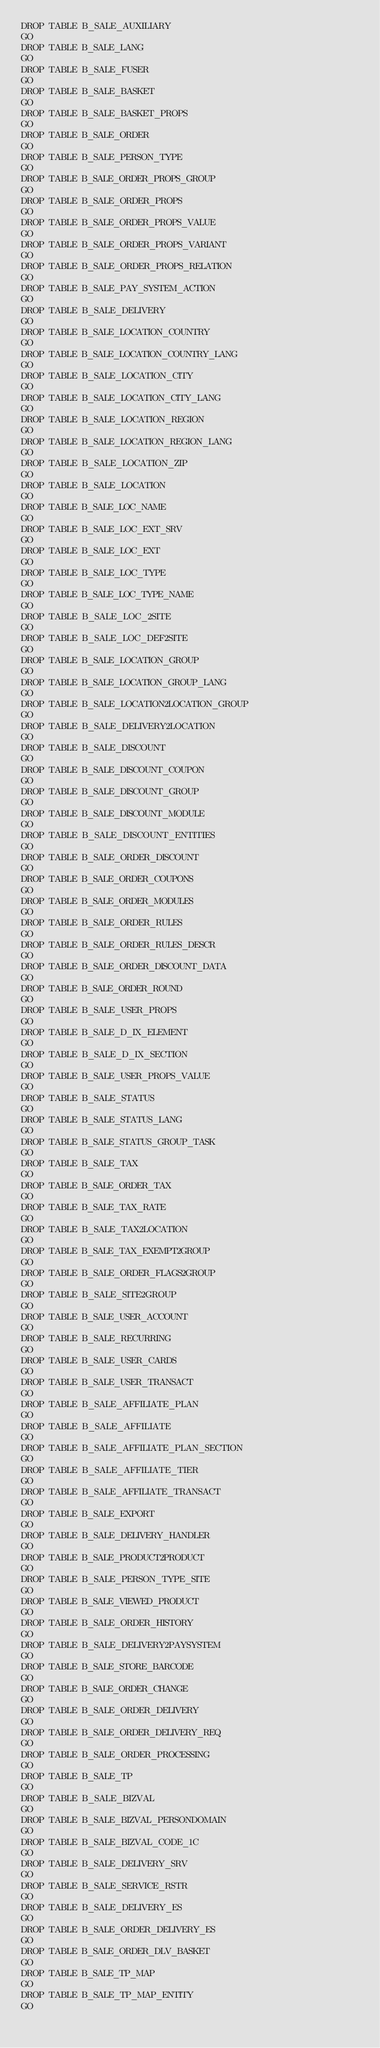Convert code to text. <code><loc_0><loc_0><loc_500><loc_500><_SQL_>DROP TABLE B_SALE_AUXILIARY
GO
DROP TABLE B_SALE_LANG
GO
DROP TABLE B_SALE_FUSER
GO
DROP TABLE B_SALE_BASKET
GO
DROP TABLE B_SALE_BASKET_PROPS
GO
DROP TABLE B_SALE_ORDER
GO
DROP TABLE B_SALE_PERSON_TYPE
GO
DROP TABLE B_SALE_ORDER_PROPS_GROUP
GO
DROP TABLE B_SALE_ORDER_PROPS
GO
DROP TABLE B_SALE_ORDER_PROPS_VALUE
GO
DROP TABLE B_SALE_ORDER_PROPS_VARIANT
GO
DROP TABLE B_SALE_ORDER_PROPS_RELATION
GO
DROP TABLE B_SALE_PAY_SYSTEM_ACTION
GO
DROP TABLE B_SALE_DELIVERY
GO
DROP TABLE B_SALE_LOCATION_COUNTRY
GO
DROP TABLE B_SALE_LOCATION_COUNTRY_LANG
GO
DROP TABLE B_SALE_LOCATION_CITY
GO
DROP TABLE B_SALE_LOCATION_CITY_LANG
GO
DROP TABLE B_SALE_LOCATION_REGION
GO
DROP TABLE B_SALE_LOCATION_REGION_LANG
GO
DROP TABLE B_SALE_LOCATION_ZIP
GO
DROP TABLE B_SALE_LOCATION
GO
DROP TABLE B_SALE_LOC_NAME
GO
DROP TABLE B_SALE_LOC_EXT_SRV
GO
DROP TABLE B_SALE_LOC_EXT
GO
DROP TABLE B_SALE_LOC_TYPE
GO
DROP TABLE B_SALE_LOC_TYPE_NAME
GO
DROP TABLE B_SALE_LOC_2SITE
GO
DROP TABLE B_SALE_LOC_DEF2SITE
GO
DROP TABLE B_SALE_LOCATION_GROUP
GO
DROP TABLE B_SALE_LOCATION_GROUP_LANG
GO
DROP TABLE B_SALE_LOCATION2LOCATION_GROUP
GO
DROP TABLE B_SALE_DELIVERY2LOCATION
GO
DROP TABLE B_SALE_DISCOUNT
GO
DROP TABLE B_SALE_DISCOUNT_COUPON
GO
DROP TABLE B_SALE_DISCOUNT_GROUP
GO
DROP TABLE B_SALE_DISCOUNT_MODULE
GO
DROP TABLE B_SALE_DISCOUNT_ENTITIES
GO
DROP TABLE B_SALE_ORDER_DISCOUNT
GO
DROP TABLE B_SALE_ORDER_COUPONS
GO
DROP TABLE B_SALE_ORDER_MODULES
GO
DROP TABLE B_SALE_ORDER_RULES
GO
DROP TABLE B_SALE_ORDER_RULES_DESCR
GO
DROP TABLE B_SALE_ORDER_DISCOUNT_DATA
GO
DROP TABLE B_SALE_ORDER_ROUND
GO
DROP TABLE B_SALE_USER_PROPS
GO
DROP TABLE B_SALE_D_IX_ELEMENT
GO
DROP TABLE B_SALE_D_IX_SECTION
GO
DROP TABLE B_SALE_USER_PROPS_VALUE
GO
DROP TABLE B_SALE_STATUS
GO
DROP TABLE B_SALE_STATUS_LANG
GO
DROP TABLE B_SALE_STATUS_GROUP_TASK
GO
DROP TABLE B_SALE_TAX
GO
DROP TABLE B_SALE_ORDER_TAX
GO
DROP TABLE B_SALE_TAX_RATE
GO
DROP TABLE B_SALE_TAX2LOCATION
GO
DROP TABLE B_SALE_TAX_EXEMPT2GROUP
GO
DROP TABLE B_SALE_ORDER_FLAGS2GROUP
GO
DROP TABLE B_SALE_SITE2GROUP
GO
DROP TABLE B_SALE_USER_ACCOUNT
GO
DROP TABLE B_SALE_RECURRING
GO
DROP TABLE B_SALE_USER_CARDS
GO
DROP TABLE B_SALE_USER_TRANSACT
GO
DROP TABLE B_SALE_AFFILIATE_PLAN
GO
DROP TABLE B_SALE_AFFILIATE
GO
DROP TABLE B_SALE_AFFILIATE_PLAN_SECTION
GO
DROP TABLE B_SALE_AFFILIATE_TIER
GO
DROP TABLE B_SALE_AFFILIATE_TRANSACT
GO
DROP TABLE B_SALE_EXPORT
GO
DROP TABLE B_SALE_DELIVERY_HANDLER
GO
DROP TABLE B_SALE_PRODUCT2PRODUCT
GO
DROP TABLE B_SALE_PERSON_TYPE_SITE
GO
DROP TABLE B_SALE_VIEWED_PRODUCT
GO
DROP TABLE B_SALE_ORDER_HISTORY
GO
DROP TABLE B_SALE_DELIVERY2PAYSYSTEM
GO
DROP TABLE B_SALE_STORE_BARCODE
GO
DROP TABLE B_SALE_ORDER_CHANGE
GO
DROP TABLE B_SALE_ORDER_DELIVERY
GO
DROP TABLE B_SALE_ORDER_DELIVERY_REQ
GO
DROP TABLE B_SALE_ORDER_PROCESSING
GO
DROP TABLE B_SALE_TP
GO
DROP TABLE B_SALE_BIZVAL
GO
DROP TABLE B_SALE_BIZVAL_PERSONDOMAIN
GO
DROP TABLE B_SALE_BIZVAL_CODE_1C
GO
DROP TABLE B_SALE_DELIVERY_SRV
GO
DROP TABLE B_SALE_SERVICE_RSTR
GO
DROP TABLE B_SALE_DELIVERY_ES
GO
DROP TABLE B_SALE_ORDER_DELIVERY_ES
GO
DROP TABLE B_SALE_ORDER_DLV_BASKET
GO
DROP TABLE B_SALE_TP_MAP
GO
DROP TABLE B_SALE_TP_MAP_ENTITY
GO</code> 